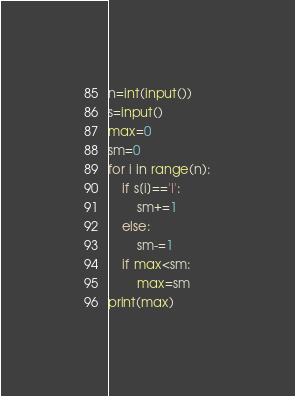<code> <loc_0><loc_0><loc_500><loc_500><_Python_>n=int(input())
s=input()
max=0
sm=0
for i in range(n):
    if s[i]=='I':
        sm+=1
    else:
        sm-=1
    if max<sm:
        max=sm
print(max)</code> 